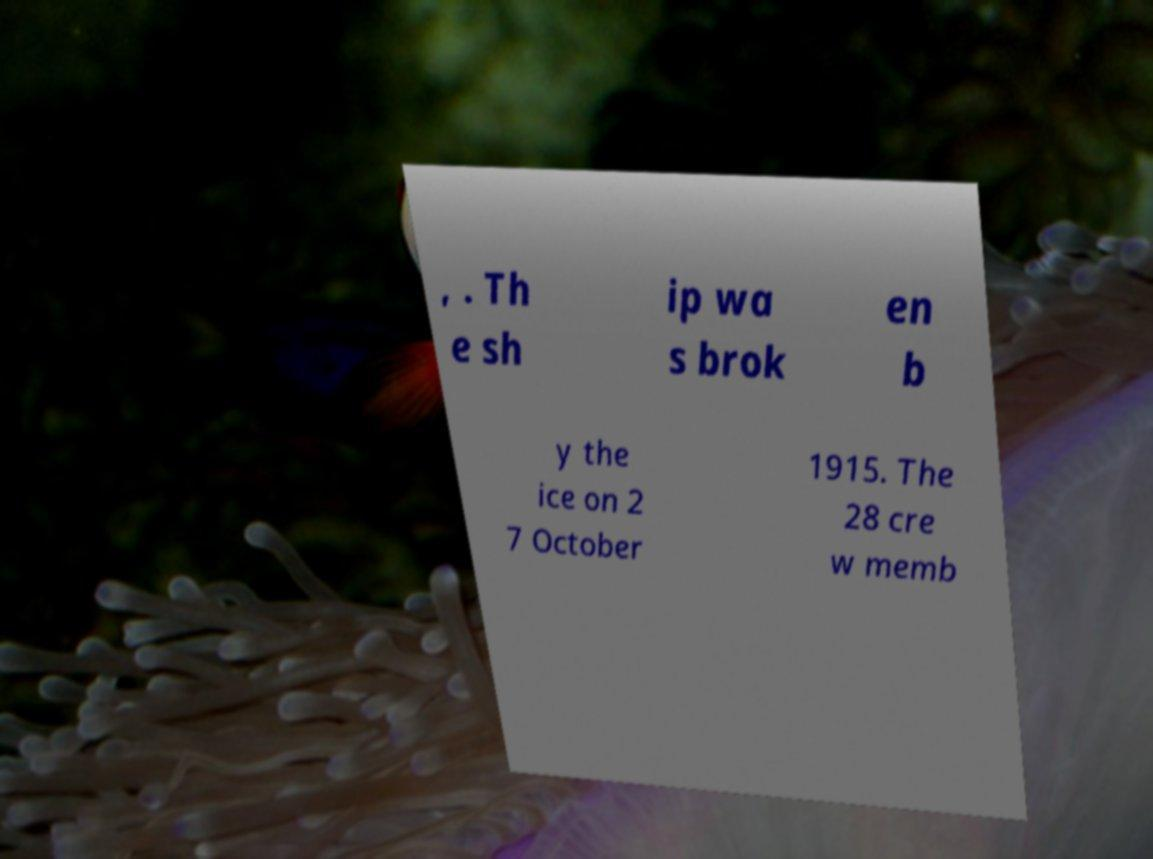There's text embedded in this image that I need extracted. Can you transcribe it verbatim? , . Th e sh ip wa s brok en b y the ice on 2 7 October 1915. The 28 cre w memb 